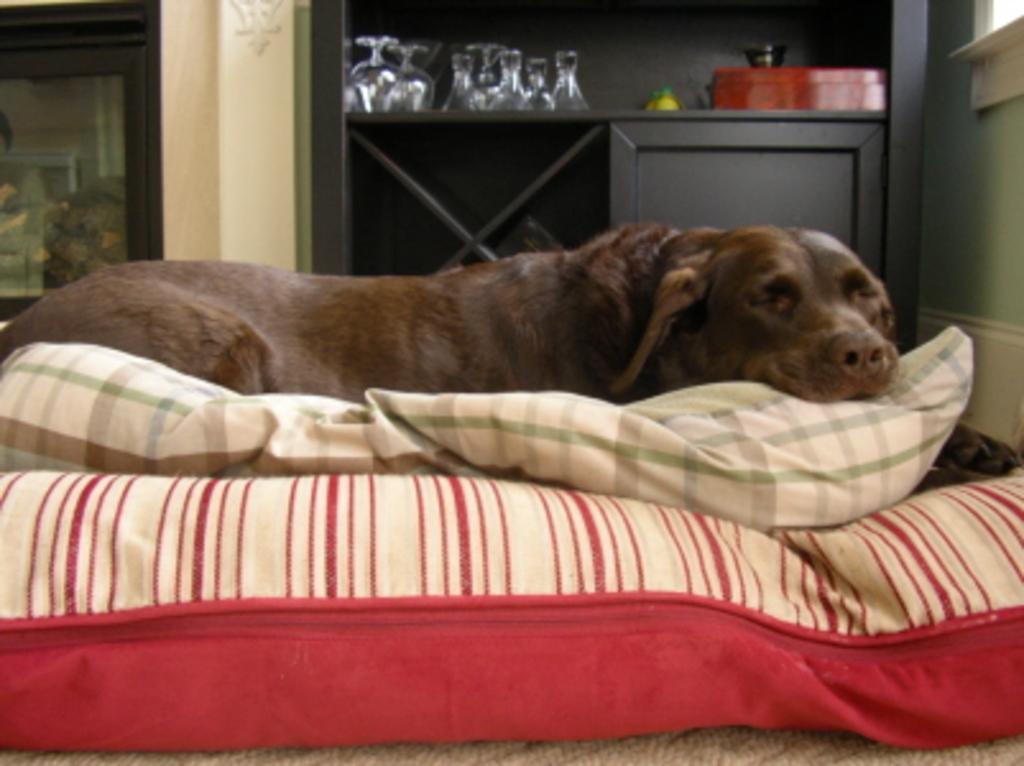How would you summarize this image in a sentence or two? In this image we can see a dog lying on a bed. On the backside we can see a door, a decor on a wall, some glasses and boxes placed on the surface and a cupboard. 